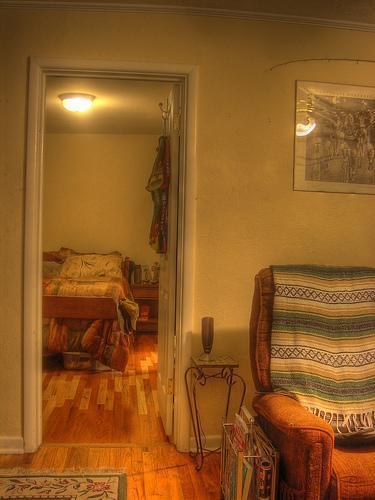How many chairs are shown?
Give a very brief answer. 1. How many lights are reflected in the posterpainting and are not visible themselves?
Give a very brief answer. 1. 